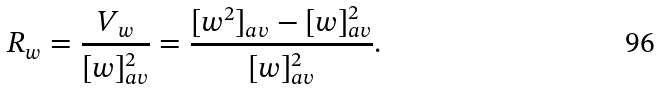Convert formula to latex. <formula><loc_0><loc_0><loc_500><loc_500>R _ { w } = \frac { V _ { w } } { [ w ] _ { a v } ^ { 2 } } = \frac { [ w ^ { 2 } ] _ { a v } - [ w ] _ { a v } ^ { 2 } } { [ w ] _ { a v } ^ { 2 } } .</formula> 